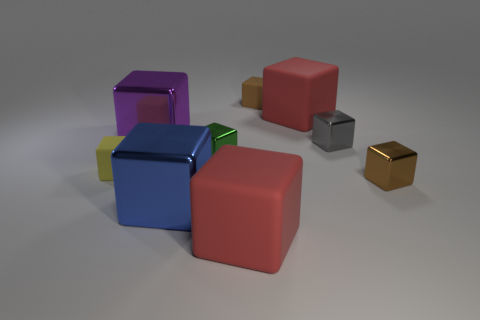Subtract 2 blocks. How many blocks are left? 7 Subtract all brown blocks. How many blocks are left? 7 Subtract all large red blocks. How many blocks are left? 7 Subtract all red blocks. Subtract all yellow balls. How many blocks are left? 7 Add 1 small red matte cubes. How many objects exist? 10 Add 6 small green objects. How many small green objects exist? 7 Subtract 1 green cubes. How many objects are left? 8 Subtract all purple things. Subtract all purple objects. How many objects are left? 7 Add 2 small gray metal cubes. How many small gray metal cubes are left? 3 